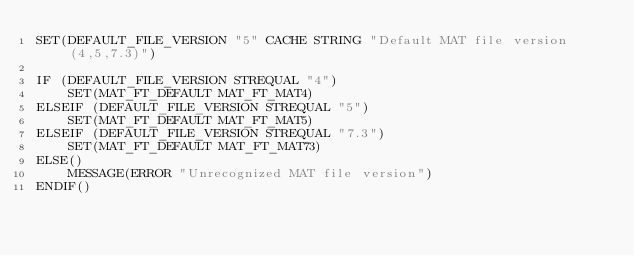Convert code to text. <code><loc_0><loc_0><loc_500><loc_500><_CMake_>SET(DEFAULT_FILE_VERSION "5" CACHE STRING "Default MAT file version (4,5,7.3)")

IF (DEFAULT_FILE_VERSION STREQUAL "4")
    SET(MAT_FT_DEFAULT MAT_FT_MAT4)
ELSEIF (DEFAULT_FILE_VERSION STREQUAL "5")
    SET(MAT_FT_DEFAULT MAT_FT_MAT5)
ELSEIF (DEFAULT_FILE_VERSION STREQUAL "7.3")
    SET(MAT_FT_DEFAULT MAT_FT_MAT73)
ELSE()
    MESSAGE(ERROR "Unrecognized MAT file version")
ENDIF()
</code> 